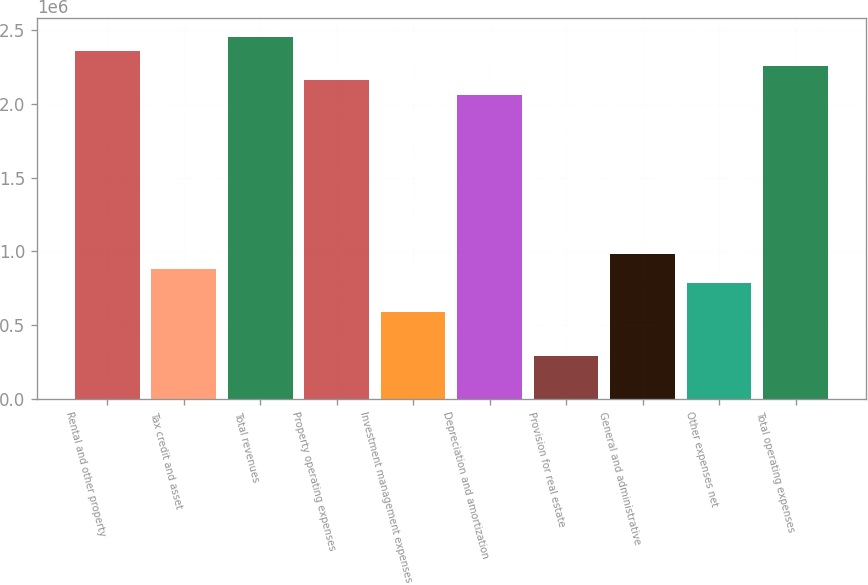Convert chart. <chart><loc_0><loc_0><loc_500><loc_500><bar_chart><fcel>Rental and other property<fcel>Tax credit and asset<fcel>Total revenues<fcel>Property operating expenses<fcel>Investment management expenses<fcel>Depreciation and amortization<fcel>Provision for real estate<fcel>General and administrative<fcel>Other expenses net<fcel>Total operating expenses<nl><fcel>2.35661e+06<fcel>883727<fcel>2.4548e+06<fcel>2.16022e+06<fcel>589152<fcel>2.06203e+06<fcel>294576<fcel>981919<fcel>785535<fcel>2.25841e+06<nl></chart> 